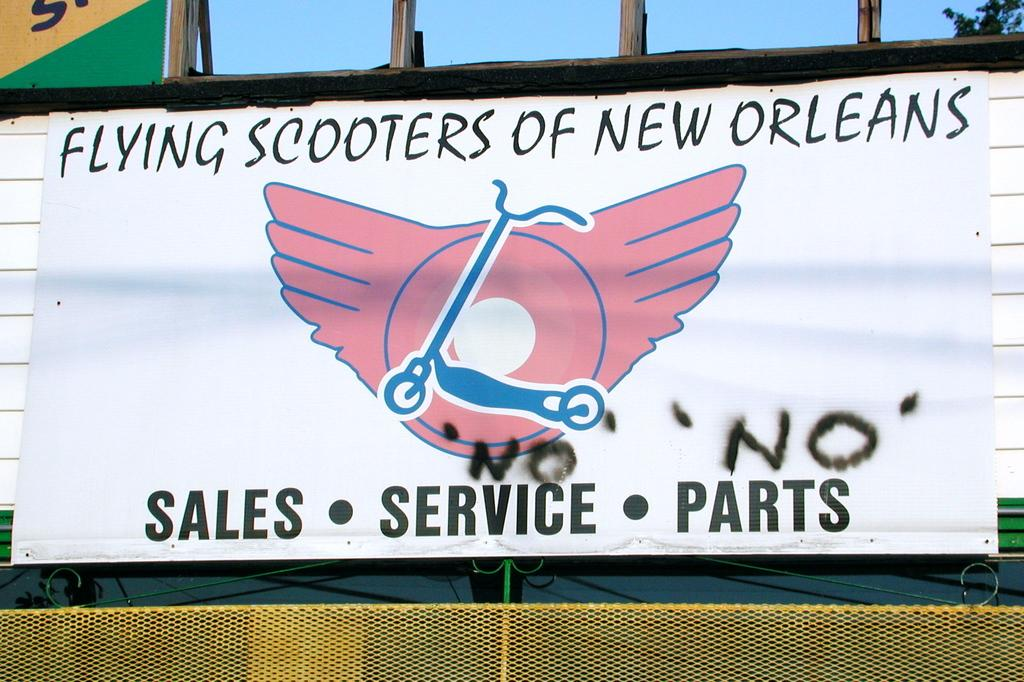<image>
Write a terse but informative summary of the picture. A billboard titled Flying Scooters of New Orleans. 